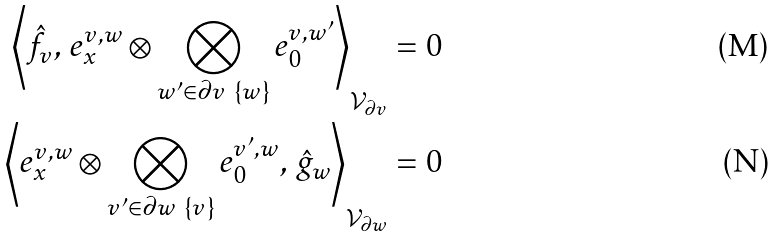<formula> <loc_0><loc_0><loc_500><loc_500>\left \langle \hat { f } _ { v } , \, e ^ { v , w } _ { x } \otimes \bigotimes _ { w ^ { \prime } \in \partial v \ \{ w \} } e ^ { v , w ^ { \prime } } _ { 0 } \right \rangle _ { \mathcal { V } _ { \partial v } } & = 0 \\ \left \langle e ^ { v , w } _ { x } \otimes \bigotimes _ { v ^ { \prime } \in \partial w \ \{ v \} } e ^ { v ^ { \prime } , w } _ { 0 } , \, \hat { g } _ { w } \right \rangle _ { \mathcal { V } _ { \partial w } } & = 0</formula> 